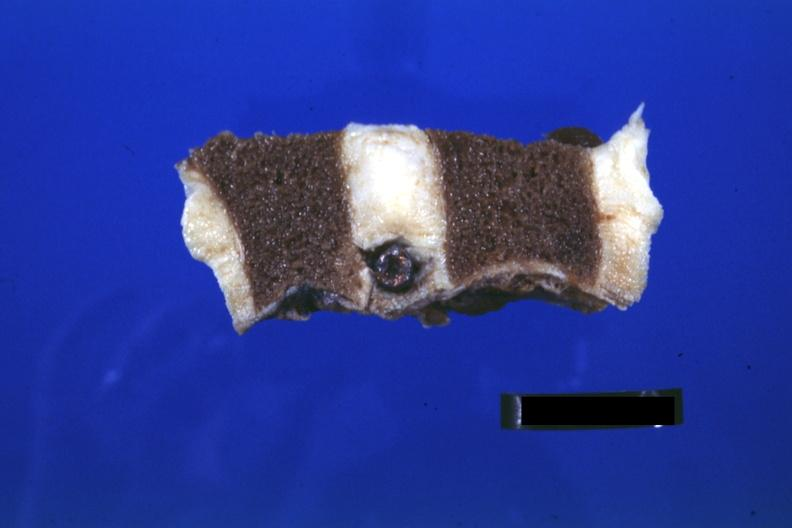does metastatic adenocarcinoma show probably natural color nice view of bullet in intervertebral disc t12-l1?
Answer the question using a single word or phrase. No 